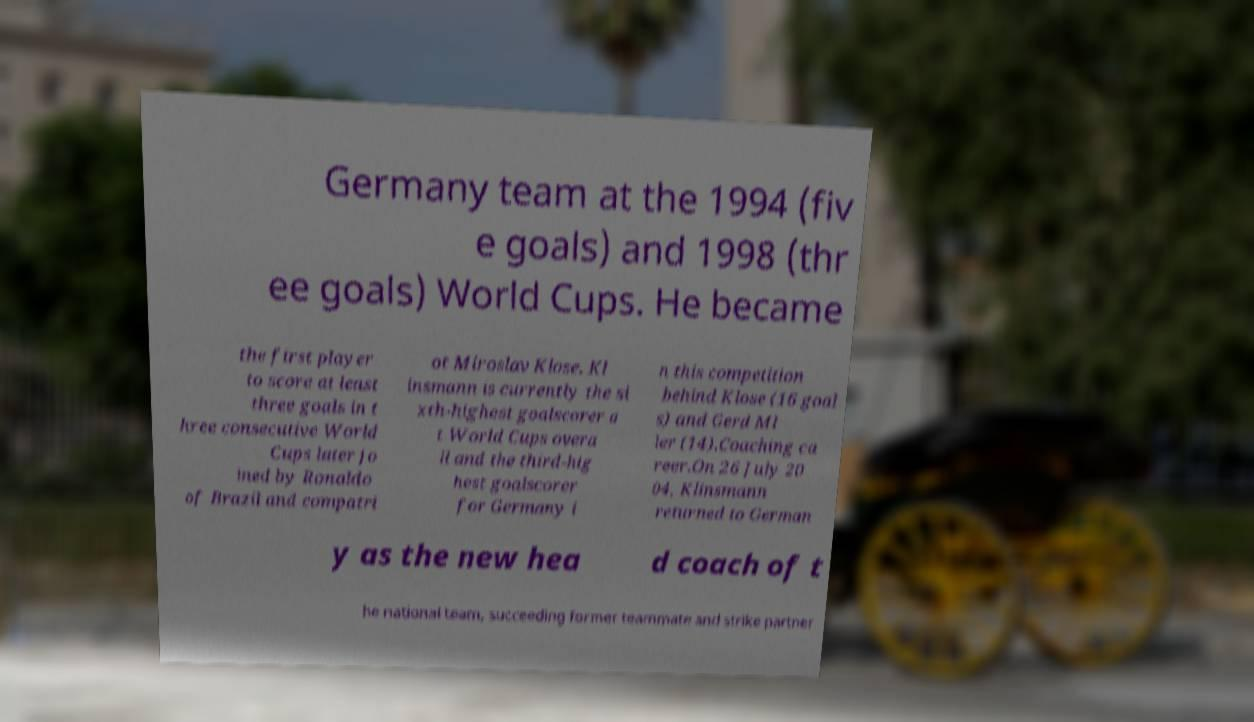Could you assist in decoding the text presented in this image and type it out clearly? Germany team at the 1994 (fiv e goals) and 1998 (thr ee goals) World Cups. He became the first player to score at least three goals in t hree consecutive World Cups later jo ined by Ronaldo of Brazil and compatri ot Miroslav Klose. Kl insmann is currently the si xth-highest goalscorer a t World Cups overa ll and the third-hig hest goalscorer for Germany i n this competition behind Klose (16 goal s) and Gerd Ml ler (14).Coaching ca reer.On 26 July 20 04, Klinsmann returned to German y as the new hea d coach of t he national team, succeeding former teammate and strike partner 